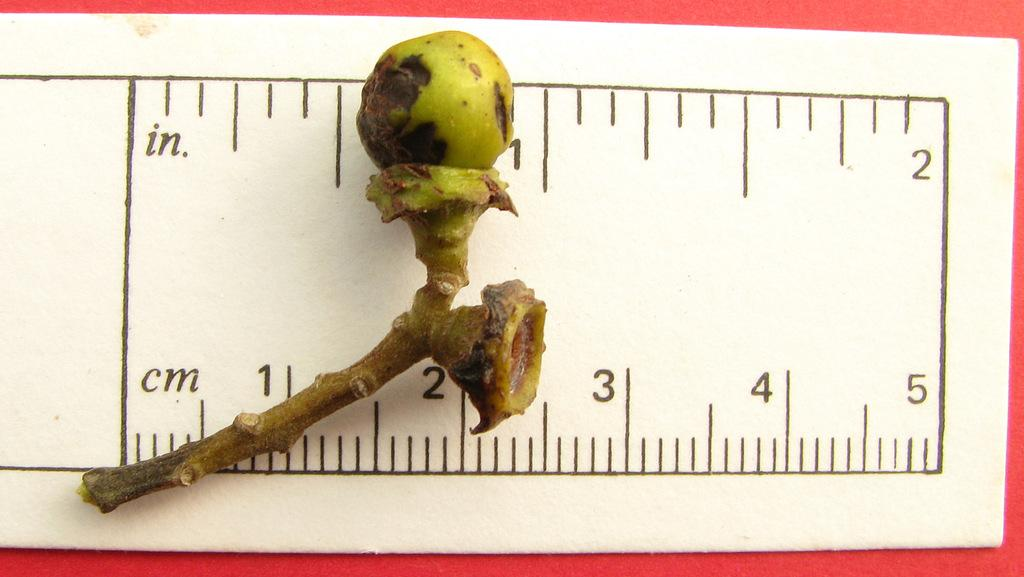<image>
Describe the image concisely. A ruler displays measurements in both centimeters and inches. 